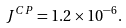Convert formula to latex. <formula><loc_0><loc_0><loc_500><loc_500>J ^ { C P } = 1 . 2 \times 1 0 ^ { - 6 } .</formula> 